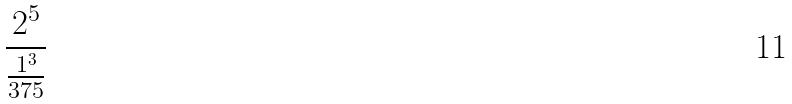<formula> <loc_0><loc_0><loc_500><loc_500>\frac { 2 ^ { 5 } } { \frac { 1 ^ { 3 } } { 3 7 5 } }</formula> 